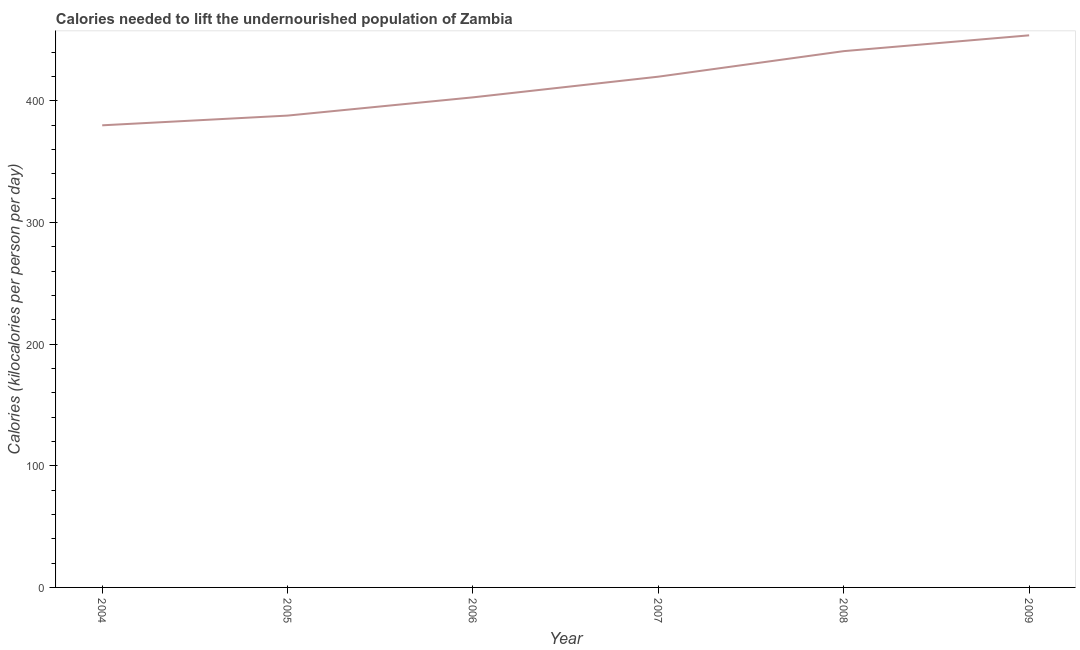What is the depth of food deficit in 2009?
Offer a very short reply. 454. Across all years, what is the maximum depth of food deficit?
Your answer should be very brief. 454. Across all years, what is the minimum depth of food deficit?
Offer a very short reply. 380. In which year was the depth of food deficit maximum?
Make the answer very short. 2009. What is the sum of the depth of food deficit?
Make the answer very short. 2486. What is the difference between the depth of food deficit in 2004 and 2006?
Make the answer very short. -23. What is the average depth of food deficit per year?
Your answer should be compact. 414.33. What is the median depth of food deficit?
Give a very brief answer. 411.5. What is the ratio of the depth of food deficit in 2007 to that in 2008?
Give a very brief answer. 0.95. Is the sum of the depth of food deficit in 2005 and 2009 greater than the maximum depth of food deficit across all years?
Your answer should be compact. Yes. What is the difference between the highest and the lowest depth of food deficit?
Make the answer very short. 74. In how many years, is the depth of food deficit greater than the average depth of food deficit taken over all years?
Make the answer very short. 3. How many lines are there?
Your answer should be compact. 1. How many years are there in the graph?
Your answer should be very brief. 6. Are the values on the major ticks of Y-axis written in scientific E-notation?
Give a very brief answer. No. Does the graph contain any zero values?
Provide a succinct answer. No. Does the graph contain grids?
Provide a short and direct response. No. What is the title of the graph?
Your answer should be compact. Calories needed to lift the undernourished population of Zambia. What is the label or title of the X-axis?
Ensure brevity in your answer.  Year. What is the label or title of the Y-axis?
Provide a succinct answer. Calories (kilocalories per person per day). What is the Calories (kilocalories per person per day) in 2004?
Provide a succinct answer. 380. What is the Calories (kilocalories per person per day) of 2005?
Make the answer very short. 388. What is the Calories (kilocalories per person per day) of 2006?
Offer a very short reply. 403. What is the Calories (kilocalories per person per day) of 2007?
Make the answer very short. 420. What is the Calories (kilocalories per person per day) in 2008?
Provide a succinct answer. 441. What is the Calories (kilocalories per person per day) in 2009?
Ensure brevity in your answer.  454. What is the difference between the Calories (kilocalories per person per day) in 2004 and 2005?
Offer a terse response. -8. What is the difference between the Calories (kilocalories per person per day) in 2004 and 2008?
Your answer should be compact. -61. What is the difference between the Calories (kilocalories per person per day) in 2004 and 2009?
Provide a succinct answer. -74. What is the difference between the Calories (kilocalories per person per day) in 2005 and 2006?
Your response must be concise. -15. What is the difference between the Calories (kilocalories per person per day) in 2005 and 2007?
Your answer should be very brief. -32. What is the difference between the Calories (kilocalories per person per day) in 2005 and 2008?
Make the answer very short. -53. What is the difference between the Calories (kilocalories per person per day) in 2005 and 2009?
Your answer should be very brief. -66. What is the difference between the Calories (kilocalories per person per day) in 2006 and 2007?
Give a very brief answer. -17. What is the difference between the Calories (kilocalories per person per day) in 2006 and 2008?
Your answer should be compact. -38. What is the difference between the Calories (kilocalories per person per day) in 2006 and 2009?
Keep it short and to the point. -51. What is the difference between the Calories (kilocalories per person per day) in 2007 and 2009?
Offer a terse response. -34. What is the difference between the Calories (kilocalories per person per day) in 2008 and 2009?
Provide a succinct answer. -13. What is the ratio of the Calories (kilocalories per person per day) in 2004 to that in 2006?
Your answer should be very brief. 0.94. What is the ratio of the Calories (kilocalories per person per day) in 2004 to that in 2007?
Give a very brief answer. 0.91. What is the ratio of the Calories (kilocalories per person per day) in 2004 to that in 2008?
Your answer should be compact. 0.86. What is the ratio of the Calories (kilocalories per person per day) in 2004 to that in 2009?
Keep it short and to the point. 0.84. What is the ratio of the Calories (kilocalories per person per day) in 2005 to that in 2006?
Ensure brevity in your answer.  0.96. What is the ratio of the Calories (kilocalories per person per day) in 2005 to that in 2007?
Offer a very short reply. 0.92. What is the ratio of the Calories (kilocalories per person per day) in 2005 to that in 2009?
Your answer should be compact. 0.85. What is the ratio of the Calories (kilocalories per person per day) in 2006 to that in 2007?
Provide a succinct answer. 0.96. What is the ratio of the Calories (kilocalories per person per day) in 2006 to that in 2008?
Keep it short and to the point. 0.91. What is the ratio of the Calories (kilocalories per person per day) in 2006 to that in 2009?
Provide a short and direct response. 0.89. What is the ratio of the Calories (kilocalories per person per day) in 2007 to that in 2009?
Offer a very short reply. 0.93. What is the ratio of the Calories (kilocalories per person per day) in 2008 to that in 2009?
Your answer should be very brief. 0.97. 